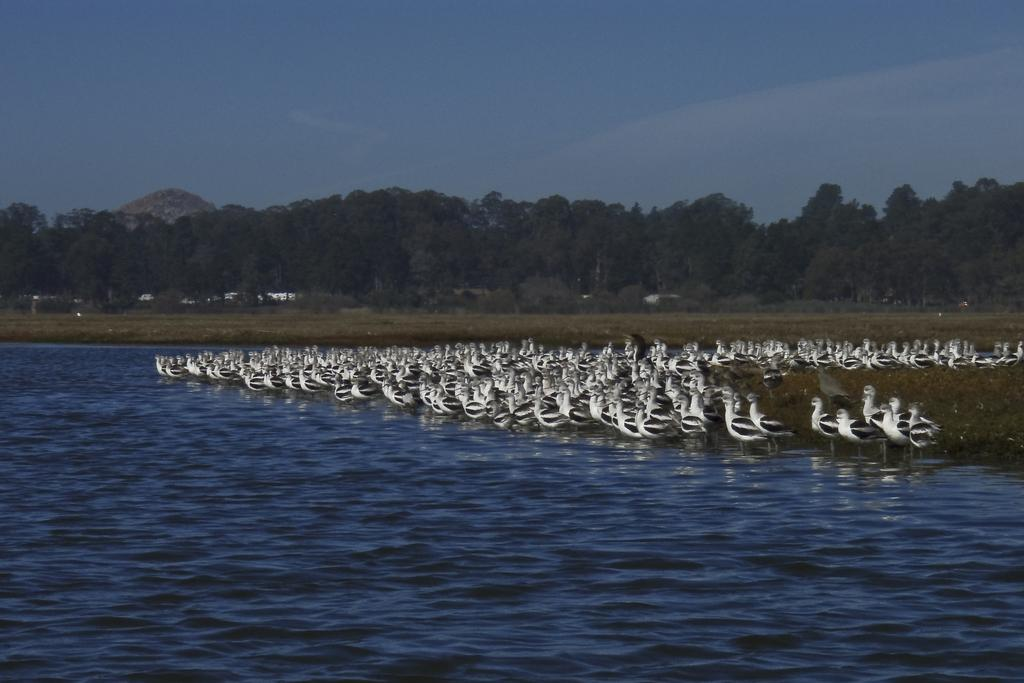What type of animals can be seen in the image? There are ducks in the water. What else can be seen in the water besides the ducks? There are trees visible in the water. What part of the natural environment is visible in the image? The sky is visible in the image. What type of vegetable is floating in the water in the image? There is no vegetable present in the image; it features ducks and trees in the water. Can you see a chess game being played in the image? There is no chess game present in the image. 